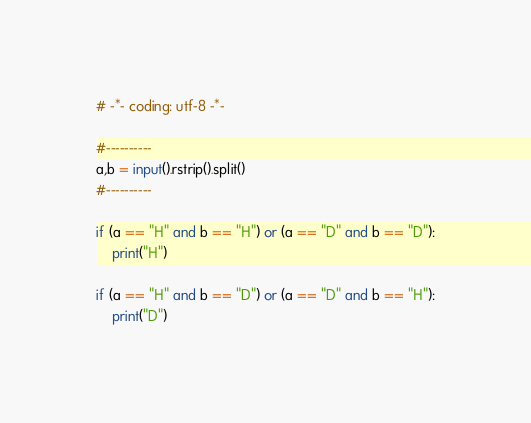<code> <loc_0><loc_0><loc_500><loc_500><_Python_># -*- coding: utf-8 -*-

#----------
a,b = input().rstrip().split()
#----------

if (a == "H" and b == "H") or (a == "D" and b == "D"):
    print("H")

if (a == "H" and b == "D") or (a == "D" and b == "H"):
    print("D")
</code> 